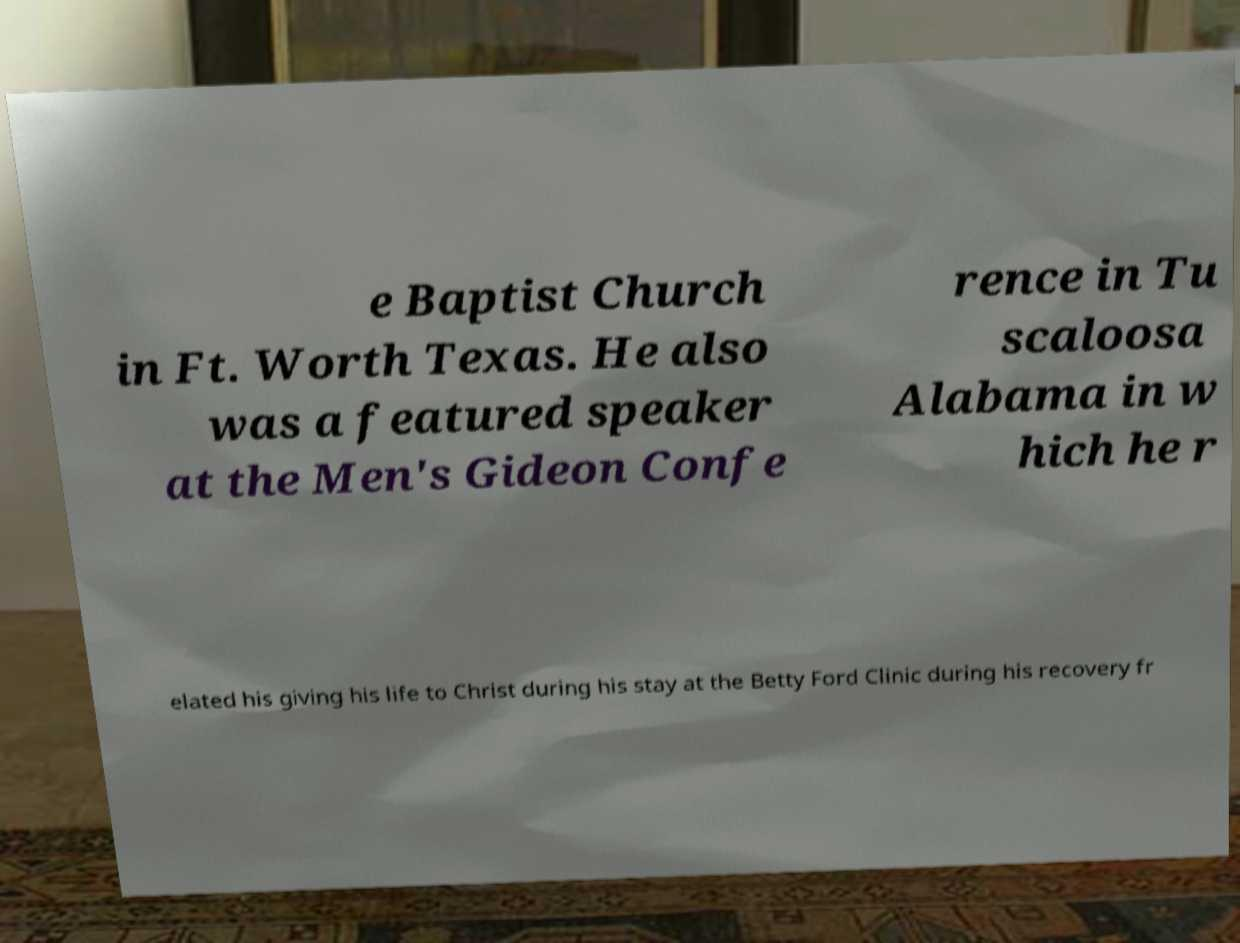Could you assist in decoding the text presented in this image and type it out clearly? e Baptist Church in Ft. Worth Texas. He also was a featured speaker at the Men's Gideon Confe rence in Tu scaloosa Alabama in w hich he r elated his giving his life to Christ during his stay at the Betty Ford Clinic during his recovery fr 